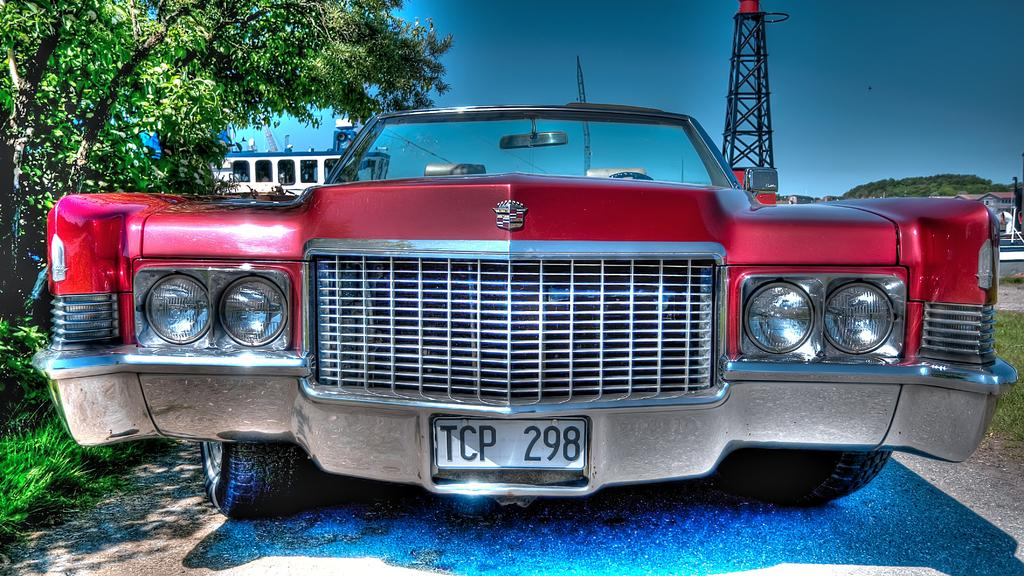What is the main subject in the middle of the image? There is a car in the middle of the image. What can be seen in the background of the image? There are trees, a boat, a tower, a hill, and the sky visible in the background of the image. What is present at the bottom of the image? There is grass and land at the bottom of the image. What type of sweater is the person wearing on the seashore in the image? There is no person wearing a sweater or any seashore present in the image. 